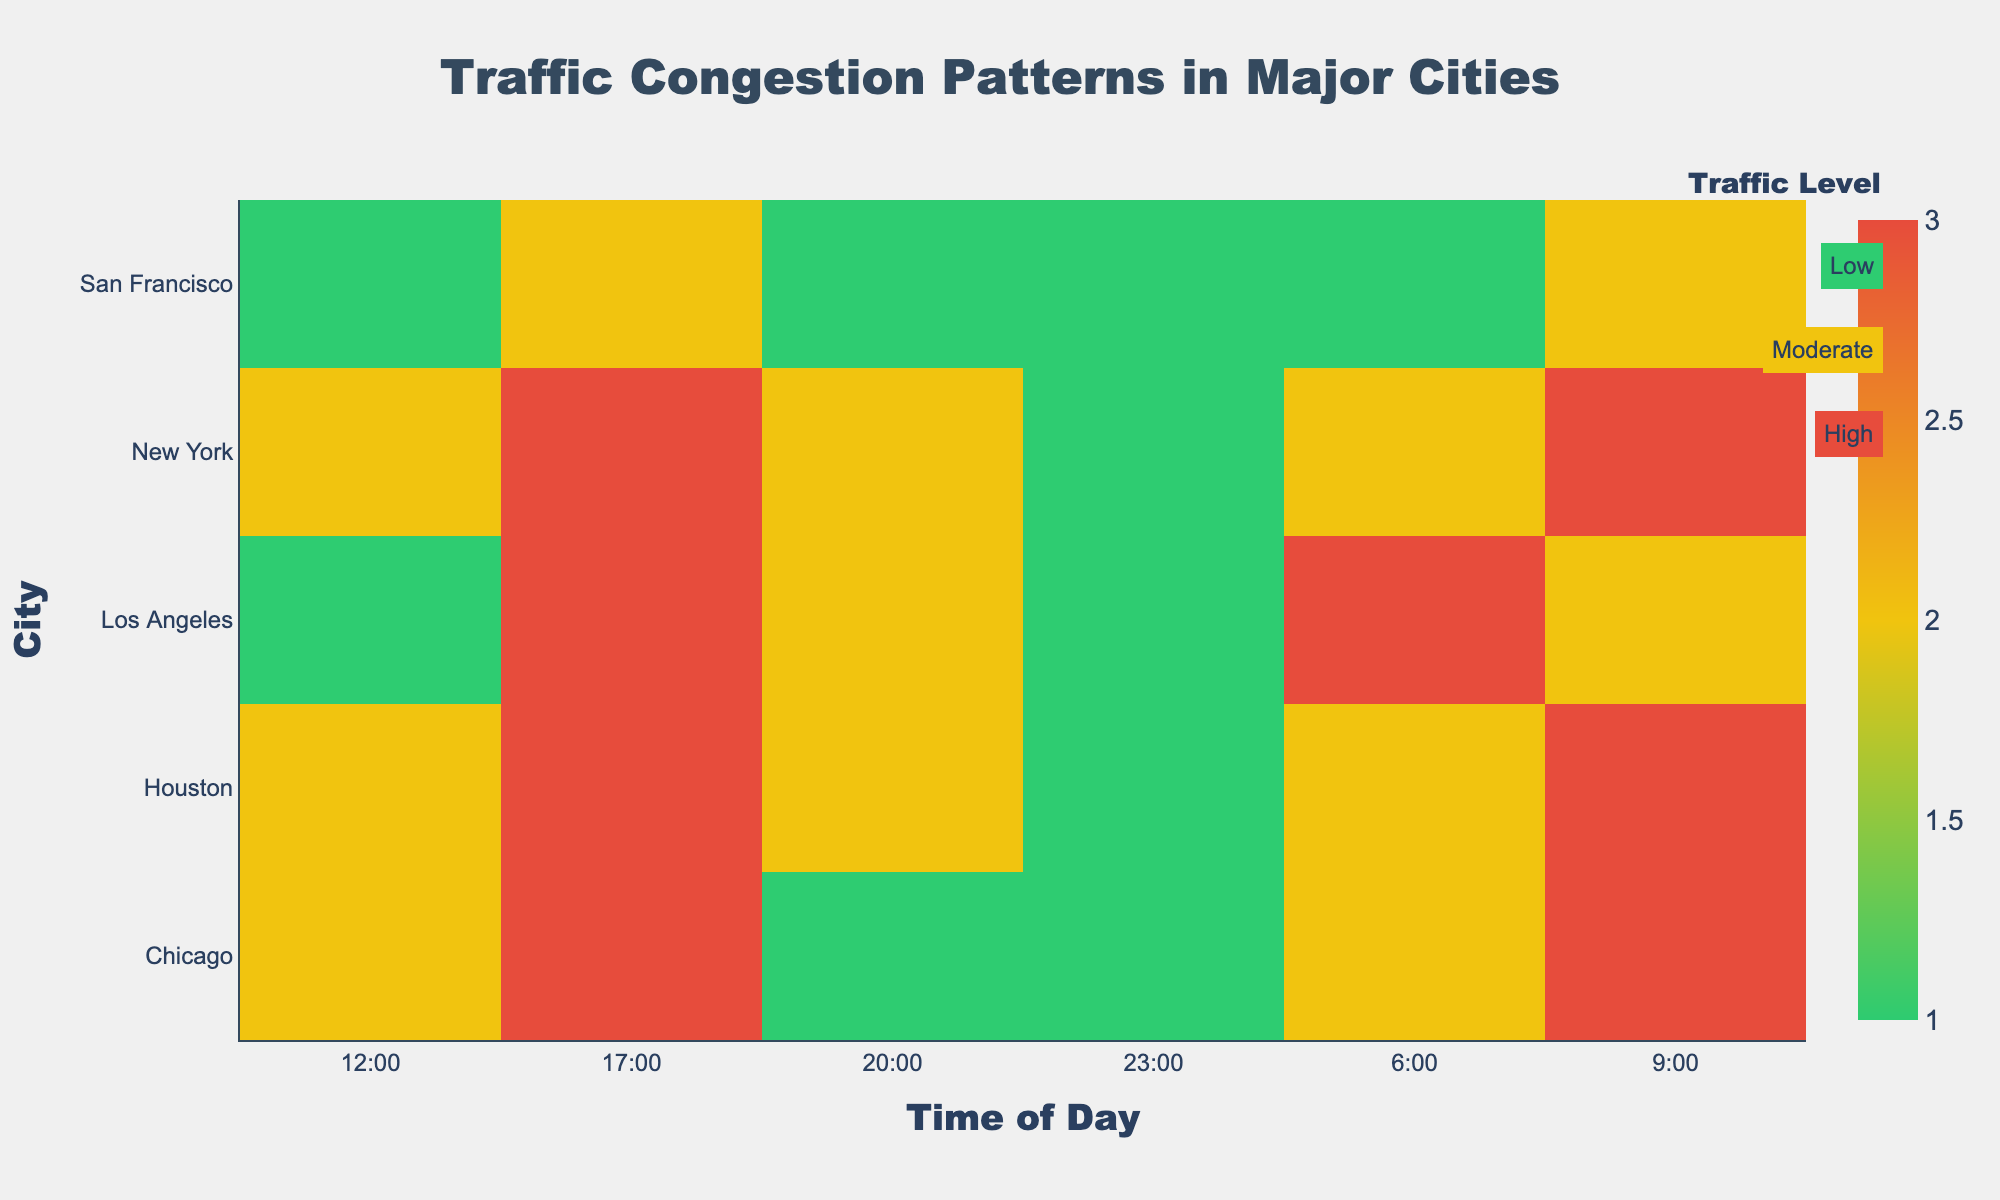What is the title of the heatmap? The title is the text displayed at the top of the heatmap, which provides an overview of what the heatmap is depicting.
Answer: Traffic Congestion Patterns in Major Cities Which city has the highest traffic congestion at 6:00? Look at the heatmap and find the highest traffic level at 6:00. The corresponding city will be the answer.
Answer: Los Angeles What is the traffic congestion level in Chicago at 17:00? Find the row for Chicago and the column for 17:00 on the heatmap to see the traffic congestion level.
Answer: High Which city shows the least traffic at 9:00? Compare the traffic levels across all cities at 9:00 and identify the one with the lowest level.
Answer: San Francisco How does the traffic level in New York change from 9:00 to 17:00? Compare the traffic levels in New York at the specified times by looking at the corresponding cells in the heatmap.
Answer: It remains high At what time is traffic congestion lowest in Houston? Identify the cell with the lowest traffic level in the row corresponding to Houston and note the time.
Answer: 23:00 Compare the traffic congestion patterns of Los Angeles and San Francisco at 17:00 and 20:00. Look at the traffic levels for both cities at the specified times and compare them.
Answer: At 17:00, both have Moderate traffic; at 20:00, Los Angeles has Moderate, and San Francisco has Low What is the overall trend of traffic levels throughout the day in Chicago? Observe the traffic levels in Chicago from 6:00 to 23:00 to identify any patterns or trends.
Answer: Moderate at 6:00, High at 9:00 and 17:00, Moderate at 12:00, Low at 20:00 and 23:00 Which city shows the most consistent traffic congestion throughout the day? Identify the city whose traffic levels are most stable (least variation) across different times.
Answer: San Francisco 